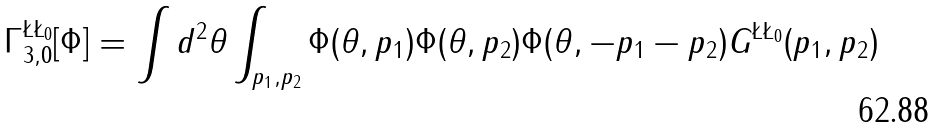Convert formula to latex. <formula><loc_0><loc_0><loc_500><loc_500>\Gamma _ { 3 , 0 } ^ { \L \L _ { 0 } } [ \Phi ] = \int d ^ { 2 } \theta \int _ { p _ { 1 } , p _ { 2 } } \Phi ( \theta , p _ { 1 } ) \Phi ( \theta , p _ { 2 } ) \Phi ( \theta , - p _ { 1 } - p _ { 2 } ) G ^ { \L \L _ { 0 } } ( p _ { 1 } , p _ { 2 } )</formula> 